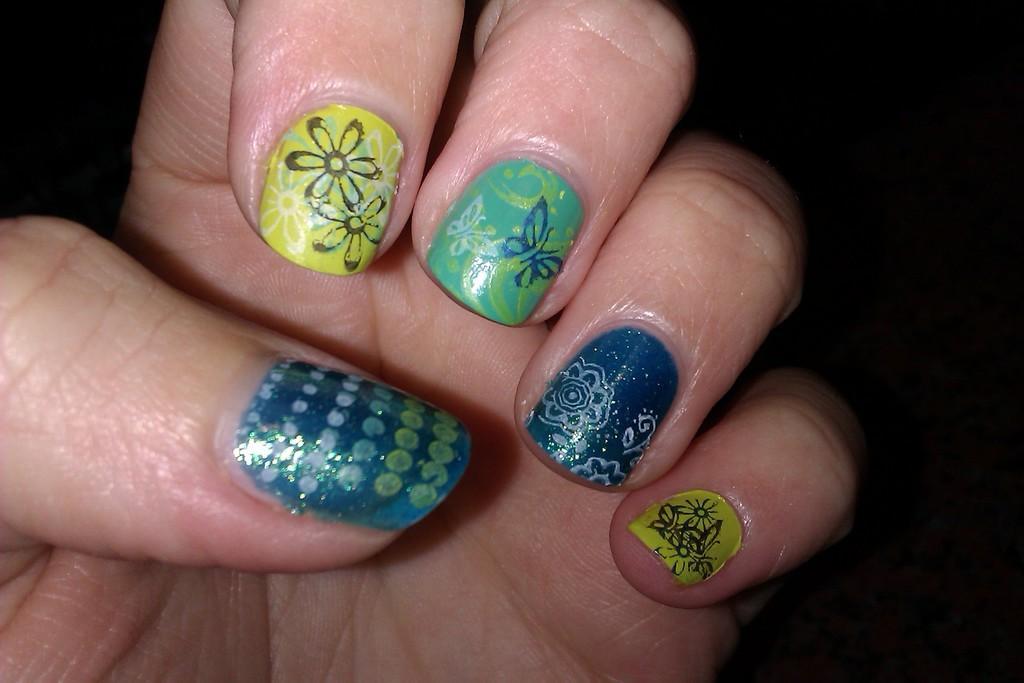Describe this image in one or two sentences. In this picture we can see a person hand with nail painting on nails and in the background it is dark. 